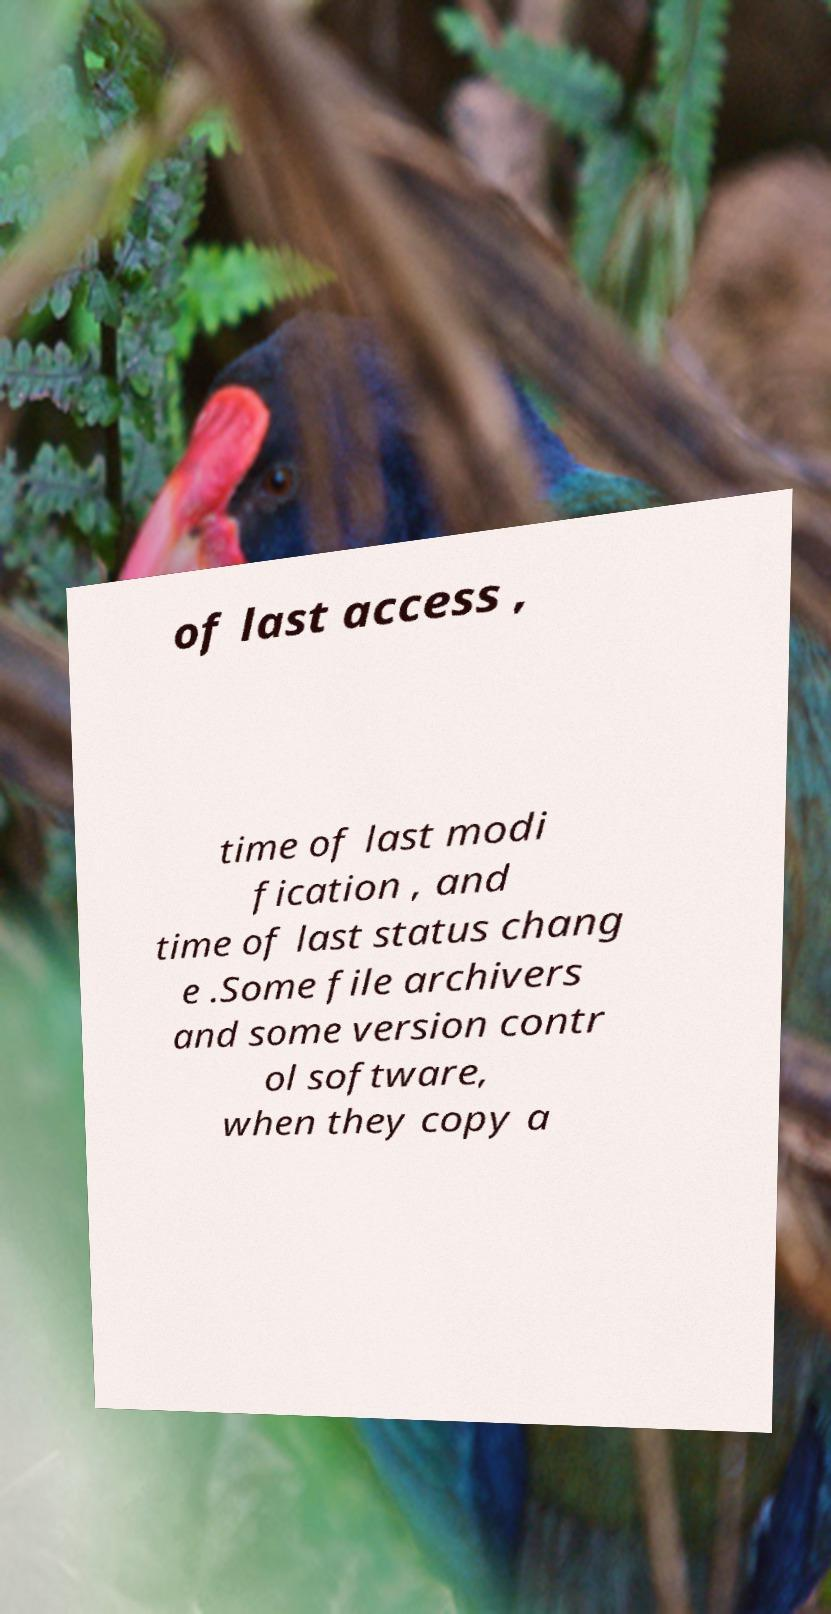Could you extract and type out the text from this image? of last access , time of last modi fication , and time of last status chang e .Some file archivers and some version contr ol software, when they copy a 